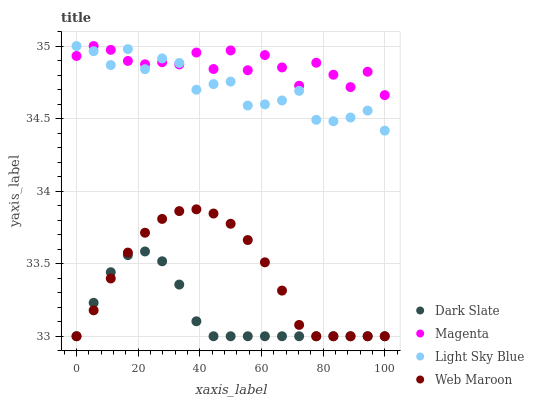Does Dark Slate have the minimum area under the curve?
Answer yes or no. Yes. Does Magenta have the maximum area under the curve?
Answer yes or no. Yes. Does Light Sky Blue have the minimum area under the curve?
Answer yes or no. No. Does Light Sky Blue have the maximum area under the curve?
Answer yes or no. No. Is Web Maroon the smoothest?
Answer yes or no. Yes. Is Magenta the roughest?
Answer yes or no. Yes. Is Light Sky Blue the smoothest?
Answer yes or no. No. Is Light Sky Blue the roughest?
Answer yes or no. No. Does Dark Slate have the lowest value?
Answer yes or no. Yes. Does Light Sky Blue have the lowest value?
Answer yes or no. No. Does Light Sky Blue have the highest value?
Answer yes or no. Yes. Does Web Maroon have the highest value?
Answer yes or no. No. Is Web Maroon less than Light Sky Blue?
Answer yes or no. Yes. Is Magenta greater than Web Maroon?
Answer yes or no. Yes. Does Light Sky Blue intersect Magenta?
Answer yes or no. Yes. Is Light Sky Blue less than Magenta?
Answer yes or no. No. Is Light Sky Blue greater than Magenta?
Answer yes or no. No. Does Web Maroon intersect Light Sky Blue?
Answer yes or no. No. 